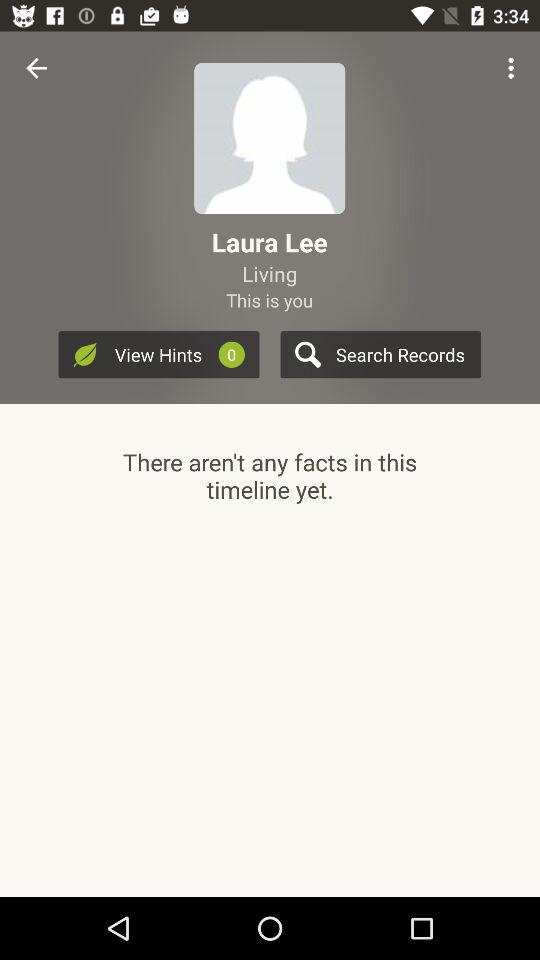Are there any facts? There are no facts. 